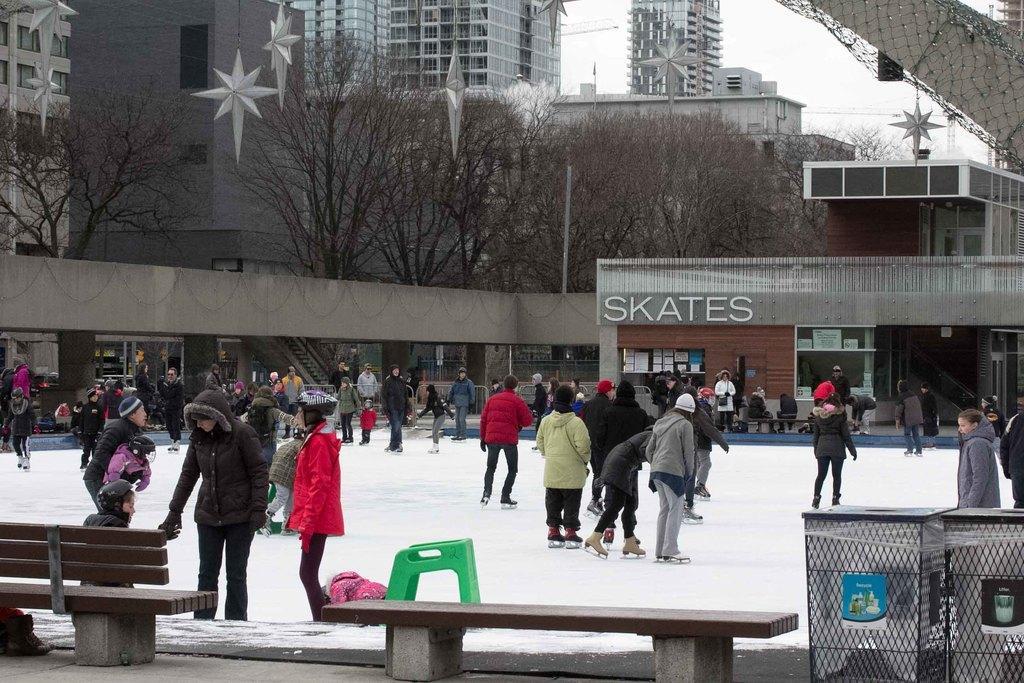How would you summarize this image in a sentence or two? In this image I can see group of people skating on the snow. In the background I can see the stall, few glass doors, few trees, buildings and the sky is in white color. 